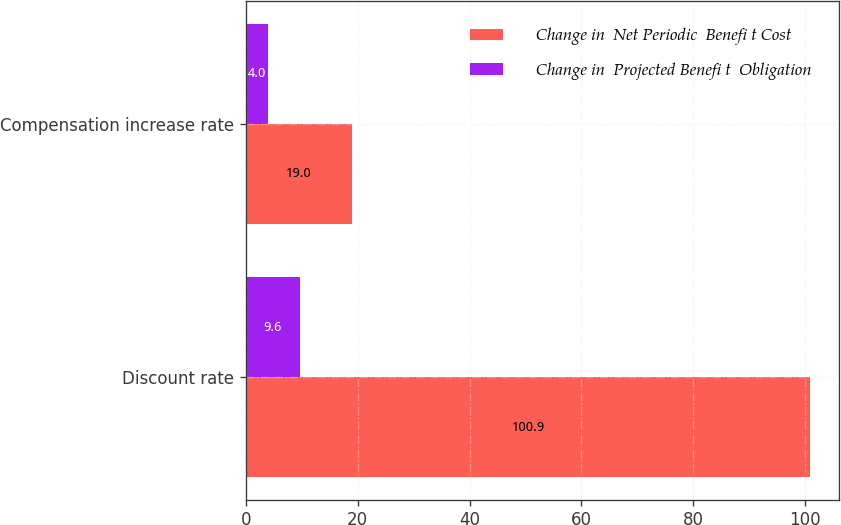Convert chart. <chart><loc_0><loc_0><loc_500><loc_500><stacked_bar_chart><ecel><fcel>Discount rate<fcel>Compensation increase rate<nl><fcel>Change in  Net Periodic  Benefi t Cost<fcel>100.9<fcel>19<nl><fcel>Change in  Projected Benefi t  Obligation<fcel>9.6<fcel>4<nl></chart> 